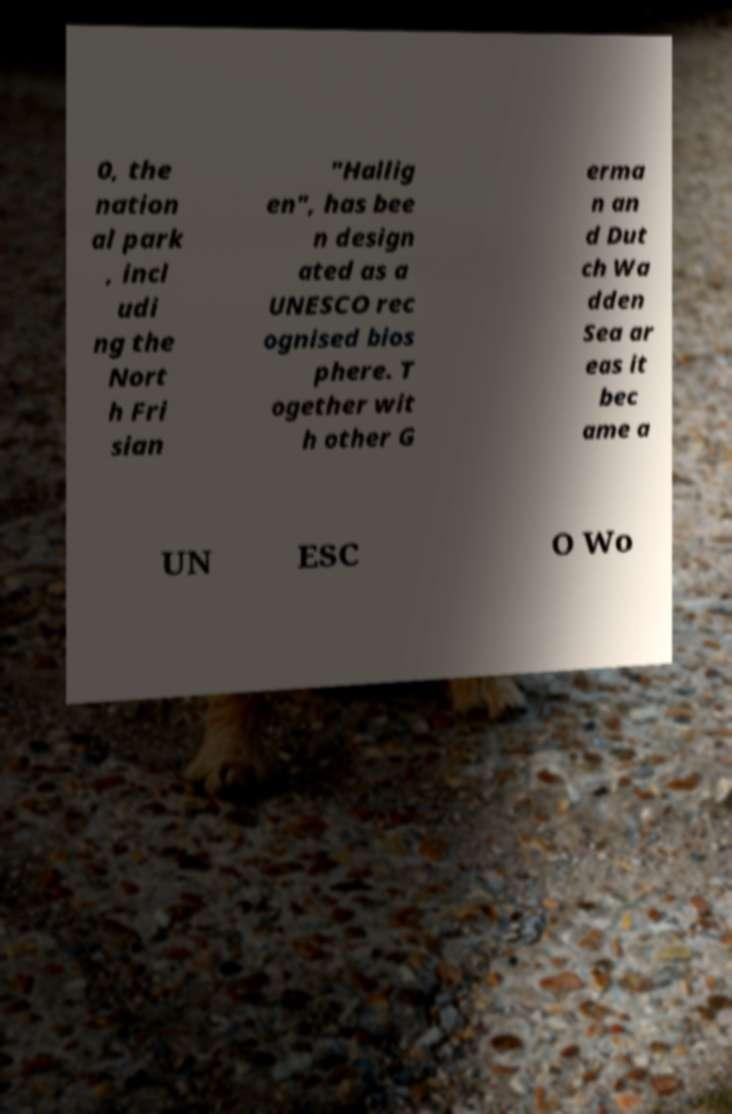Can you read and provide the text displayed in the image?This photo seems to have some interesting text. Can you extract and type it out for me? 0, the nation al park , incl udi ng the Nort h Fri sian "Hallig en", has bee n design ated as a UNESCO rec ognised bios phere. T ogether wit h other G erma n an d Dut ch Wa dden Sea ar eas it bec ame a UN ESC O Wo 